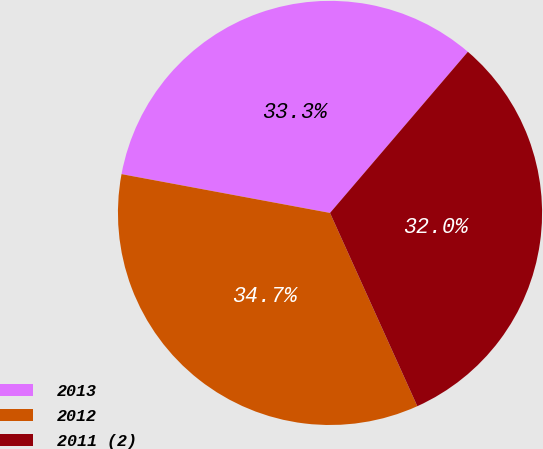<chart> <loc_0><loc_0><loc_500><loc_500><pie_chart><fcel>2013<fcel>2012<fcel>2011 (2)<nl><fcel>33.33%<fcel>34.68%<fcel>31.98%<nl></chart> 